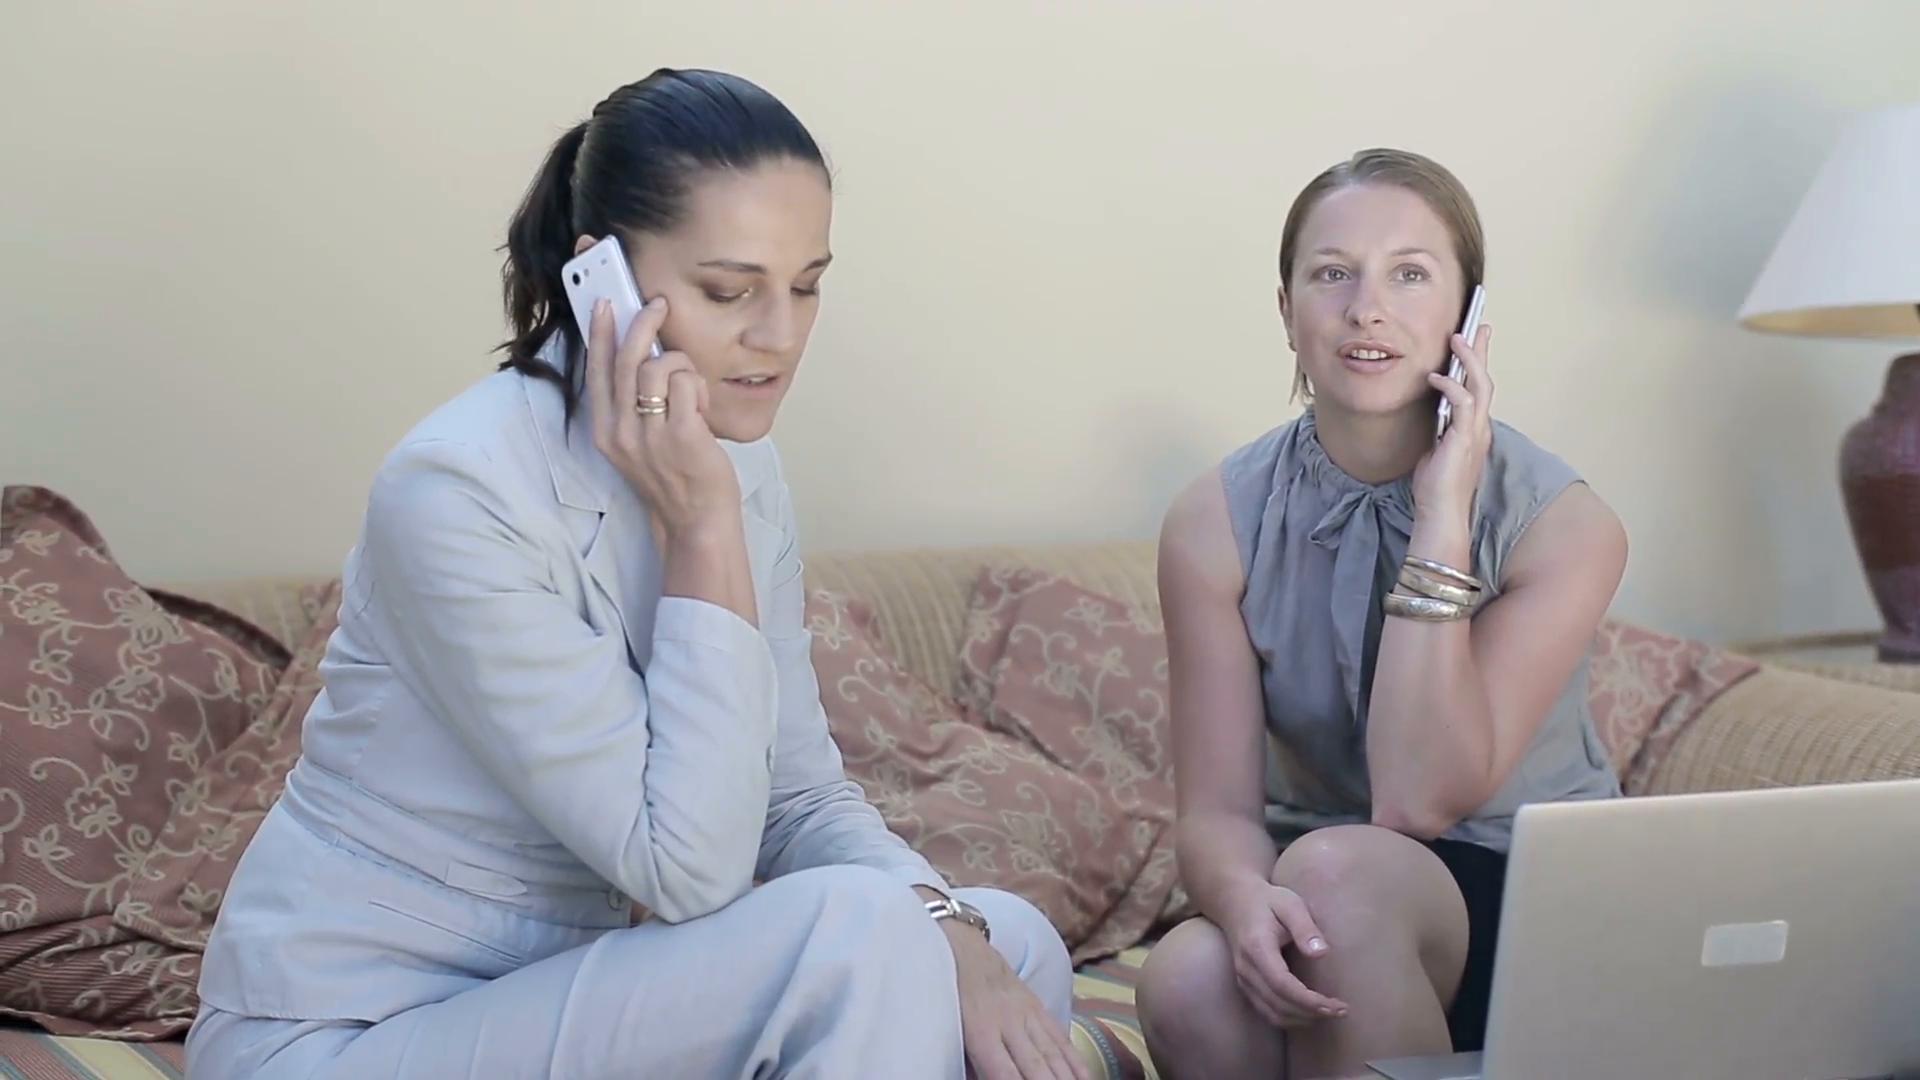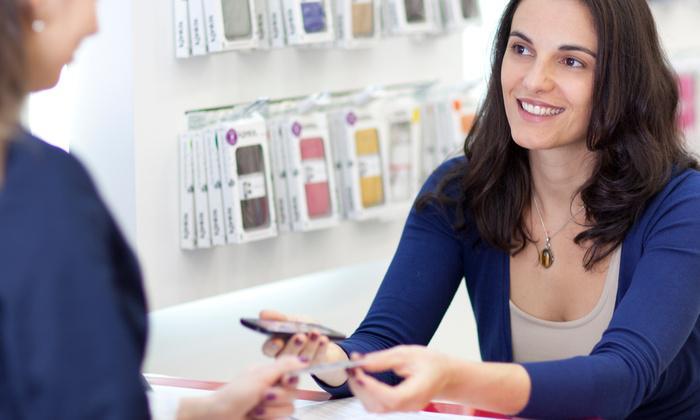The first image is the image on the left, the second image is the image on the right. Evaluate the accuracy of this statement regarding the images: "Only one person is holding a phone to their ear.". Is it true? Answer yes or no. No. The first image is the image on the left, the second image is the image on the right. For the images shown, is this caption "In the image to the left, a person is holding a phone; the phone is not up to anyone's ear." true? Answer yes or no. No. 